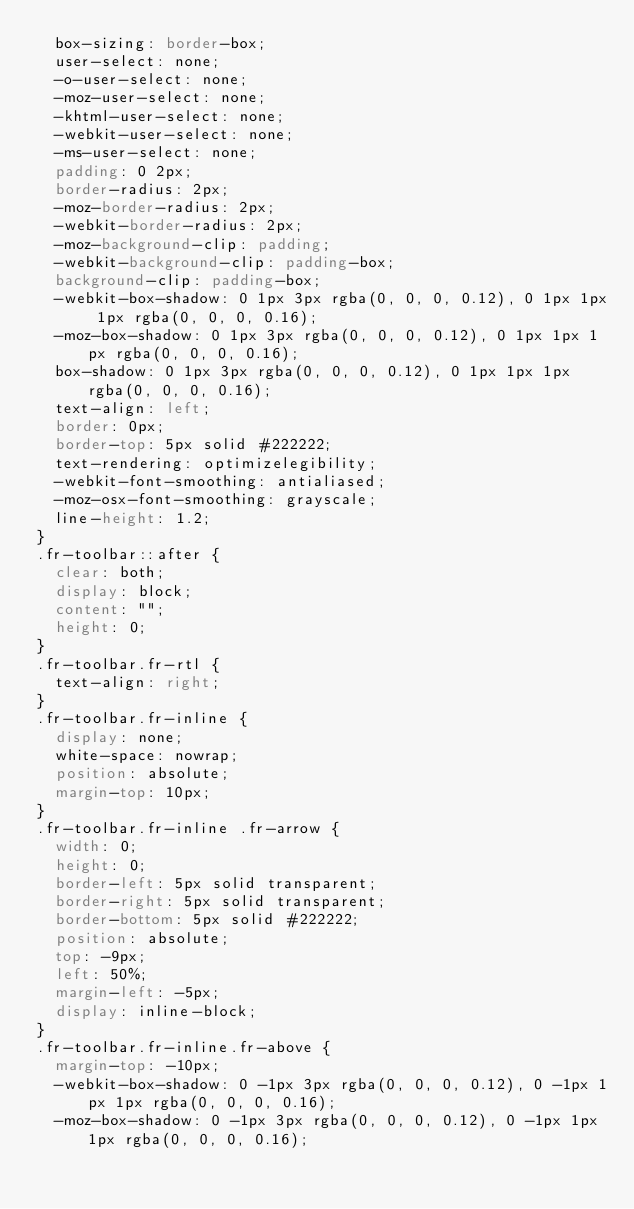<code> <loc_0><loc_0><loc_500><loc_500><_CSS_>  box-sizing: border-box;
  user-select: none;
  -o-user-select: none;
  -moz-user-select: none;
  -khtml-user-select: none;
  -webkit-user-select: none;
  -ms-user-select: none;
  padding: 0 2px;
  border-radius: 2px;
  -moz-border-radius: 2px;
  -webkit-border-radius: 2px;
  -moz-background-clip: padding;
  -webkit-background-clip: padding-box;
  background-clip: padding-box;
  -webkit-box-shadow: 0 1px 3px rgba(0, 0, 0, 0.12), 0 1px 1px 1px rgba(0, 0, 0, 0.16);
  -moz-box-shadow: 0 1px 3px rgba(0, 0, 0, 0.12), 0 1px 1px 1px rgba(0, 0, 0, 0.16);
  box-shadow: 0 1px 3px rgba(0, 0, 0, 0.12), 0 1px 1px 1px rgba(0, 0, 0, 0.16);
  text-align: left;
  border: 0px;
  border-top: 5px solid #222222;
  text-rendering: optimizelegibility;
  -webkit-font-smoothing: antialiased;
  -moz-osx-font-smoothing: grayscale;
  line-height: 1.2;
}
.fr-toolbar::after {
  clear: both;
  display: block;
  content: "";
  height: 0;
}
.fr-toolbar.fr-rtl {
  text-align: right;
}
.fr-toolbar.fr-inline {
  display: none;
  white-space: nowrap;
  position: absolute;
  margin-top: 10px;
}
.fr-toolbar.fr-inline .fr-arrow {
  width: 0;
  height: 0;
  border-left: 5px solid transparent;
  border-right: 5px solid transparent;
  border-bottom: 5px solid #222222;
  position: absolute;
  top: -9px;
  left: 50%;
  margin-left: -5px;
  display: inline-block;
}
.fr-toolbar.fr-inline.fr-above {
  margin-top: -10px;
  -webkit-box-shadow: 0 -1px 3px rgba(0, 0, 0, 0.12), 0 -1px 1px 1px rgba(0, 0, 0, 0.16);
  -moz-box-shadow: 0 -1px 3px rgba(0, 0, 0, 0.12), 0 -1px 1px 1px rgba(0, 0, 0, 0.16);</code> 